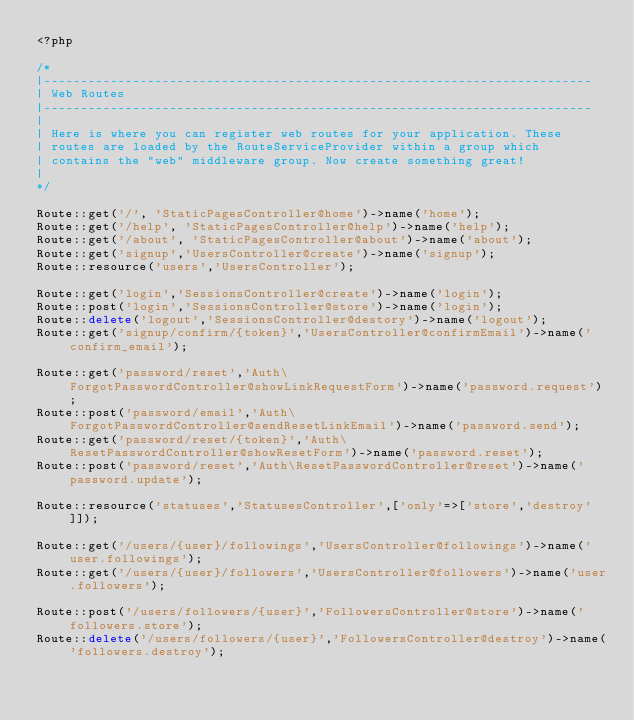Convert code to text. <code><loc_0><loc_0><loc_500><loc_500><_PHP_><?php

/*
|--------------------------------------------------------------------------
| Web Routes
|--------------------------------------------------------------------------
|
| Here is where you can register web routes for your application. These
| routes are loaded by the RouteServiceProvider within a group which
| contains the "web" middleware group. Now create something great!
|
*/

Route::get('/', 'StaticPagesController@home')->name('home');
Route::get('/help', 'StaticPagesController@help')->name('help');
Route::get('/about', 'StaticPagesController@about')->name('about');
Route::get('signup','UsersController@create')->name('signup');
Route::resource('users','UsersController');

Route::get('login','SessionsController@create')->name('login');
Route::post('login','SessionsController@store')->name('login');
Route::delete('logout','SessionsController@destory')->name('logout');
Route::get('signup/confirm/{token}','UsersController@confirmEmail')->name('confirm_email');

Route::get('password/reset','Auth\ForgotPasswordController@showLinkRequestForm')->name('password.request');
Route::post('password/email','Auth\ForgotPasswordController@sendResetLinkEmail')->name('password.send');
Route::get('password/reset/{token}','Auth\ResetPasswordController@showResetForm')->name('password.reset');
Route::post('password/reset','Auth\ResetPasswordController@reset')->name('password.update');

Route::resource('statuses','StatusesController',['only'=>['store','destroy']]);

Route::get('/users/{user}/followings','UsersController@followings')->name('user.followings');
Route::get('/users/{user}/followers','UsersController@followers')->name('user.followers');

Route::post('/users/followers/{user}','FollowersController@store')->name('followers.store');
Route::delete('/users/followers/{user}','FollowersController@destroy')->name('followers.destroy');
</code> 